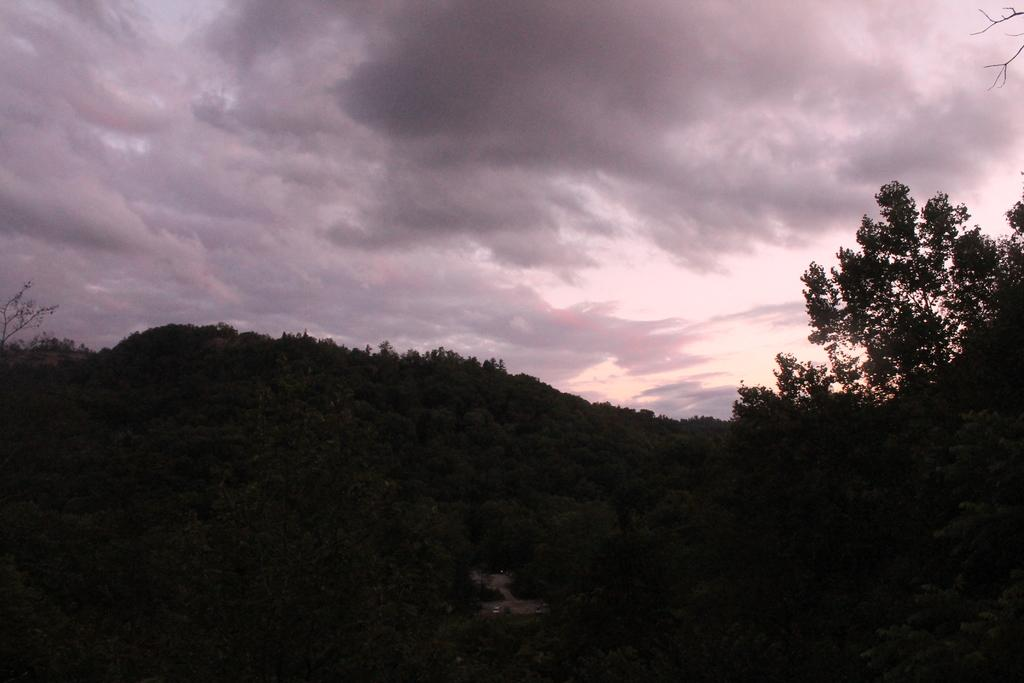What type of vegetation is visible at the bottom side of the image? There are trees at the bottom side of the image. What is visible at the top side of the image? There is sky at the top side of the image. Can you see a tiger sneezing in the image? There is no tiger or sneezing present in the image. Is there a school visible in the image? There is no school present in the image. 